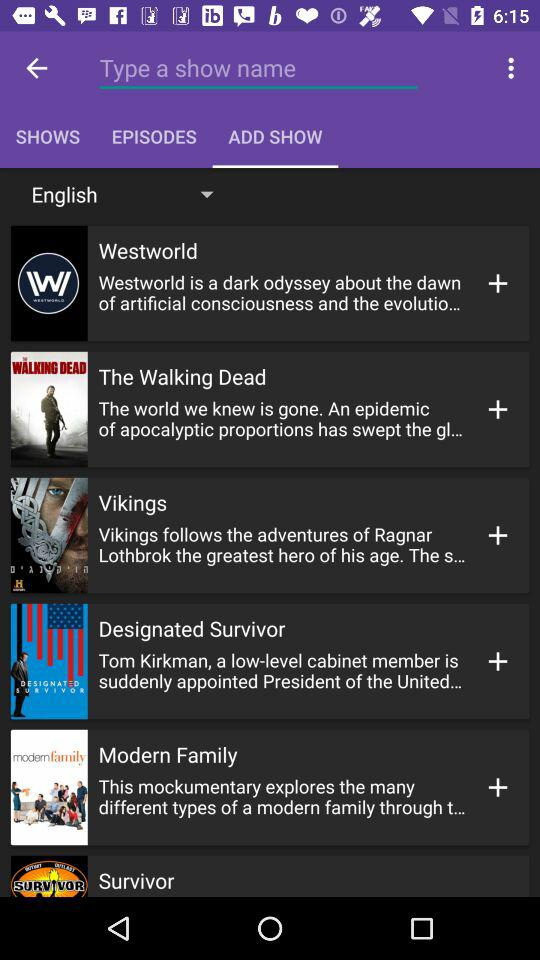Which tab is selected? The selected tab is "ADD SHOW". 